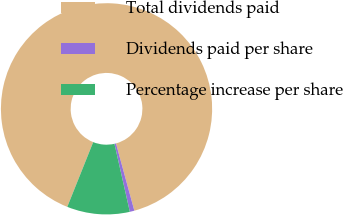<chart> <loc_0><loc_0><loc_500><loc_500><pie_chart><fcel>Total dividends paid<fcel>Dividends paid per share<fcel>Percentage increase per share<nl><fcel>89.7%<fcel>0.7%<fcel>9.6%<nl></chart> 